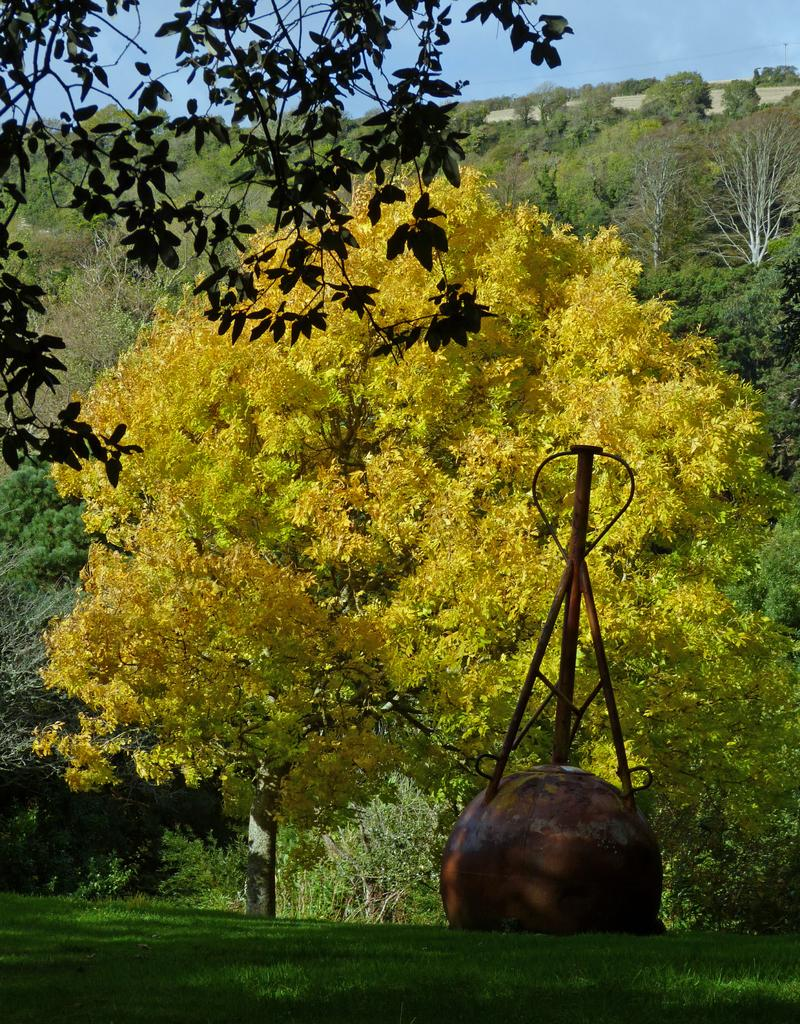What type of vegetation can be seen in the image? There are trees and plants in the image. What object can be seen in the image that is typically used for flattening surfaces? There is a roller in the image. What part of the natural environment is visible in the image? The sky is visible in the image. What type of leg can be seen supporting the horse in the image? There is no horse or leg present in the image; it features trees, plants, and a roller. 